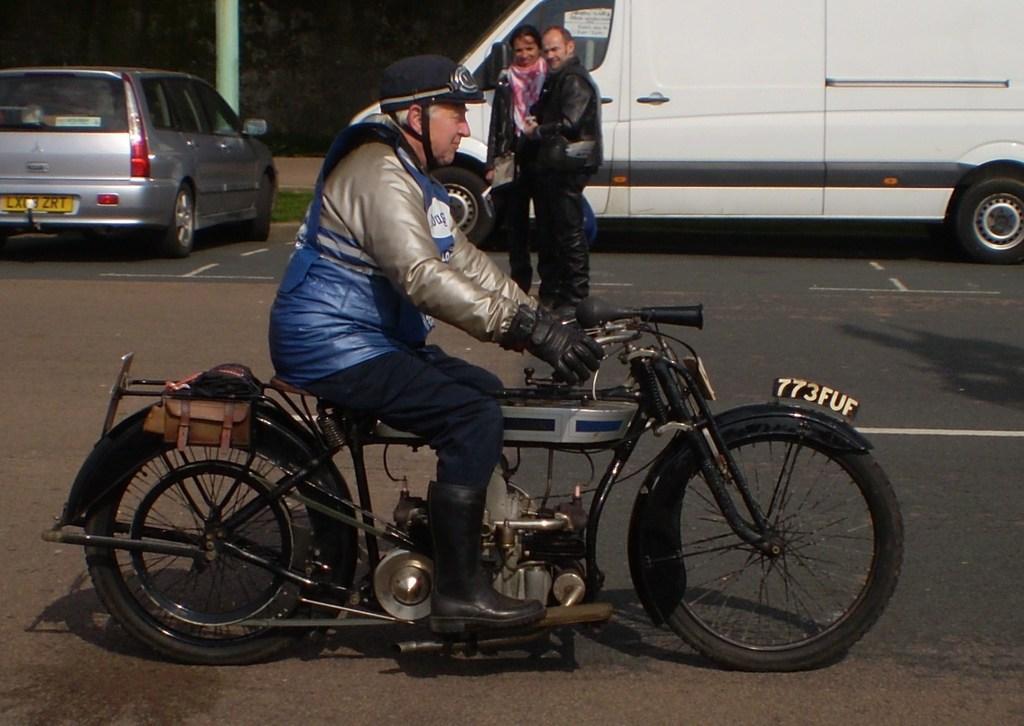Can you describe this image briefly? In this image in the front there is a man riding a vehicle. In the center there is a person standing and in the background there are cars and there is grass on the ground and there is a pillar. 